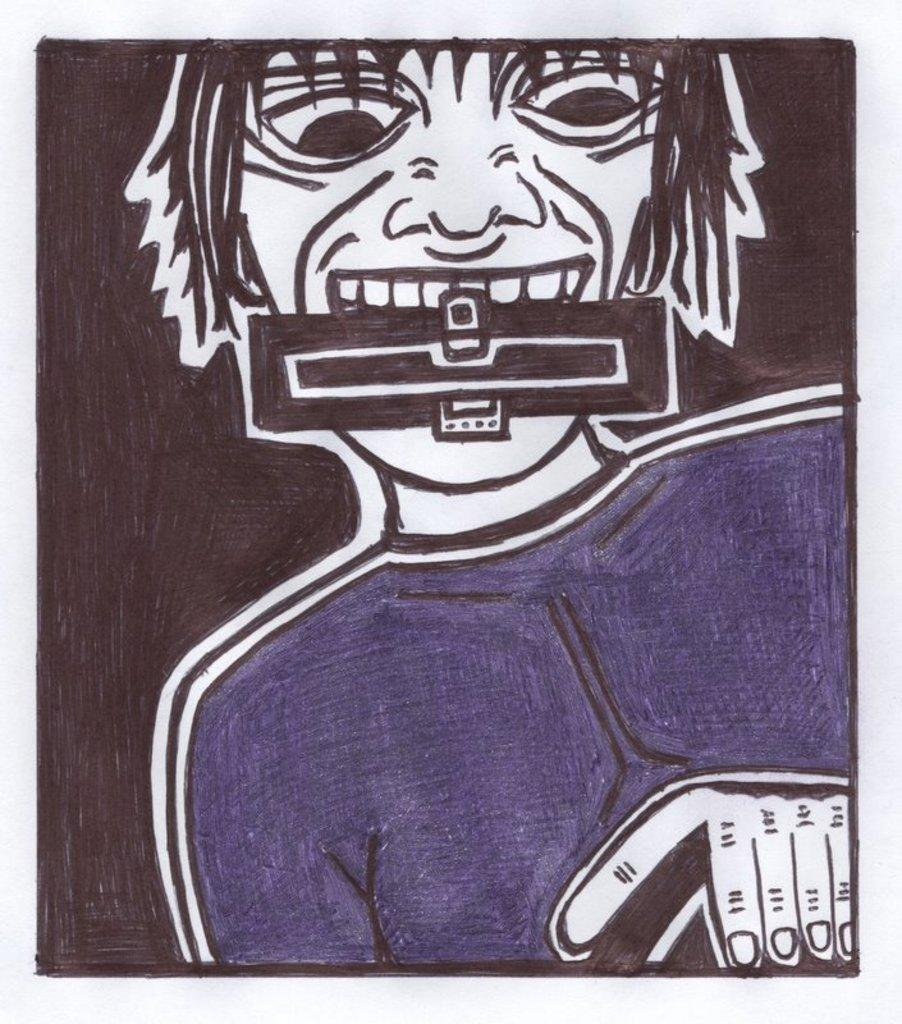What is depicted in the image? There is a drawing of a person in the image. What is the person in the drawing doing? The person is holding an object with their mouth in the drawing. How many battles are taking place in the image? There are no battles depicted in the image; it features a drawing of a person holding an object with their mouth. What shape is the square in the image? There is no square present in the image. 